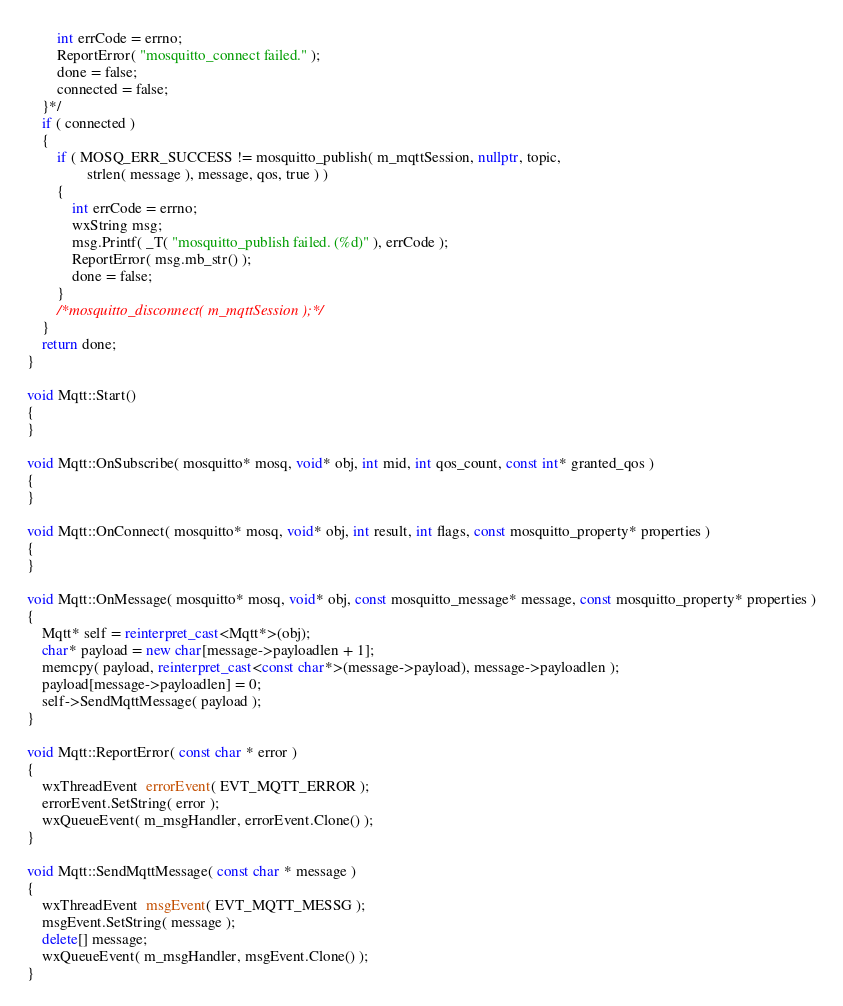<code> <loc_0><loc_0><loc_500><loc_500><_C++_>		int errCode = errno;
		ReportError( "mosquitto_connect failed." );
		done = false;
		connected = false;
	}*/
	if ( connected )
	{
		if ( MOSQ_ERR_SUCCESS != mosquitto_publish( m_mqttSession, nullptr, topic,
				strlen( message ), message, qos, true ) )
		{
			int errCode = errno;
			wxString msg;
			msg.Printf( _T( "mosquitto_publish failed. (%d)" ), errCode );
			ReportError( msg.mb_str() );
			done = false;
		}
		/*mosquitto_disconnect( m_mqttSession );*/
	}
	return done;
}

void Mqtt::Start()
{
}

void Mqtt::OnSubscribe( mosquitto* mosq, void* obj, int mid, int qos_count, const int* granted_qos )
{
}

void Mqtt::OnConnect( mosquitto* mosq, void* obj, int result, int flags, const mosquitto_property* properties )
{
}

void Mqtt::OnMessage( mosquitto* mosq, void* obj, const mosquitto_message* message, const mosquitto_property* properties )
{
	Mqtt* self = reinterpret_cast<Mqtt*>(obj);
	char* payload = new char[message->payloadlen + 1];
	memcpy( payload, reinterpret_cast<const char*>(message->payload), message->payloadlen );
	payload[message->payloadlen] = 0;
	self->SendMqttMessage( payload );
}

void Mqtt::ReportError( const char * error )
{
	wxThreadEvent  errorEvent( EVT_MQTT_ERROR );
	errorEvent.SetString( error );
	wxQueueEvent( m_msgHandler, errorEvent.Clone() );
}

void Mqtt::SendMqttMessage( const char * message )
{
	wxThreadEvent  msgEvent( EVT_MQTT_MESSG );
	msgEvent.SetString( message );
	delete[] message;
	wxQueueEvent( m_msgHandler, msgEvent.Clone() );
}
</code> 